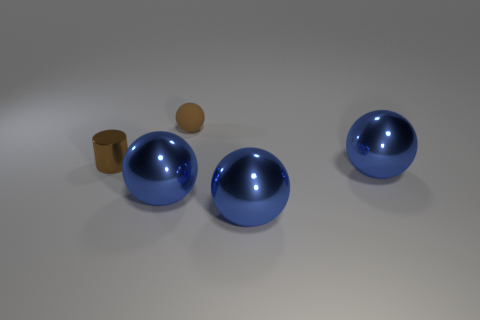There is a thing that is the same color as the matte sphere; what shape is it?
Make the answer very short. Cylinder. Are there fewer big balls that are on the left side of the brown matte thing than brown metallic cylinders?
Offer a terse response. No. Are there more small rubber objects that are in front of the metallic cylinder than big blue spheres behind the brown rubber object?
Ensure brevity in your answer.  No. Is there anything else that is the same color as the metallic cylinder?
Give a very brief answer. Yes. What material is the brown thing that is behind the tiny brown cylinder?
Give a very brief answer. Rubber. Is the size of the matte sphere the same as the brown shiny object?
Your answer should be compact. Yes. What number of other objects are the same size as the brown matte ball?
Your answer should be compact. 1. Is the color of the small metallic object the same as the rubber object?
Keep it short and to the point. Yes. The brown thing behind the brown cylinder that is on the left side of the tiny brown object that is behind the shiny cylinder is what shape?
Give a very brief answer. Sphere. What number of objects are large things to the right of the brown matte sphere or small objects right of the brown metal cylinder?
Give a very brief answer. 3. 